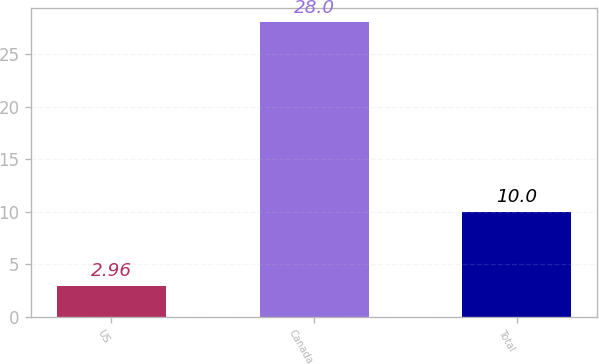Convert chart to OTSL. <chart><loc_0><loc_0><loc_500><loc_500><bar_chart><fcel>US<fcel>Canada<fcel>Total<nl><fcel>2.96<fcel>28<fcel>10<nl></chart> 